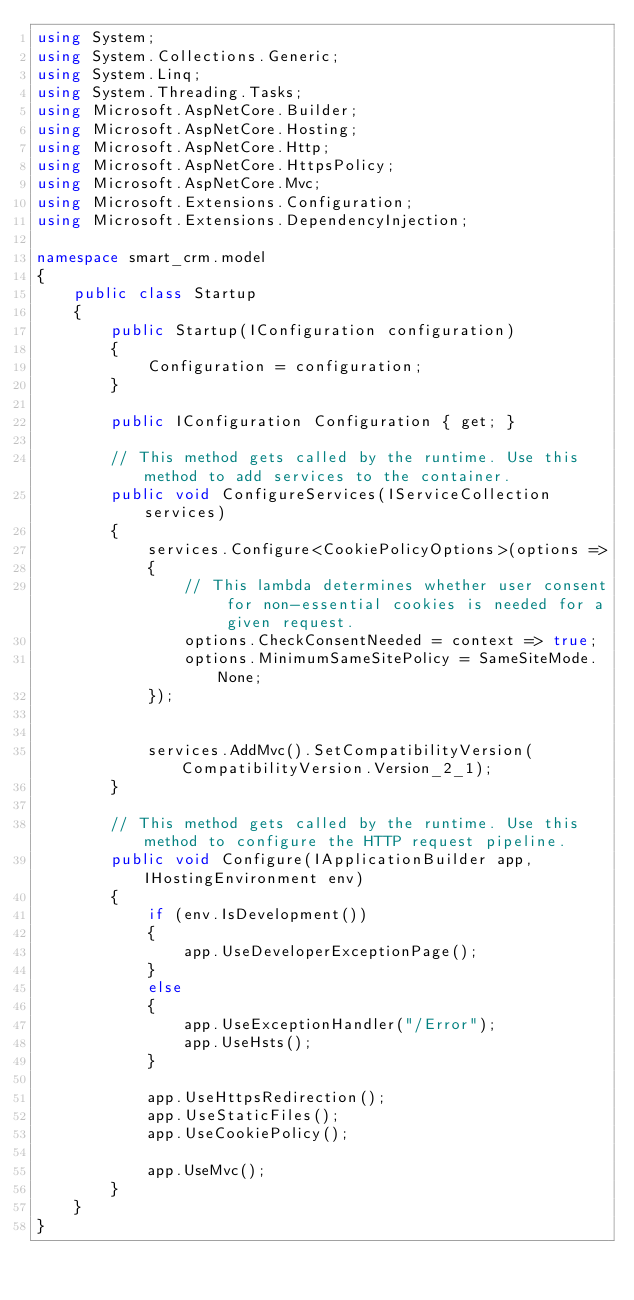<code> <loc_0><loc_0><loc_500><loc_500><_C#_>using System;
using System.Collections.Generic;
using System.Linq;
using System.Threading.Tasks;
using Microsoft.AspNetCore.Builder;
using Microsoft.AspNetCore.Hosting;
using Microsoft.AspNetCore.Http;
using Microsoft.AspNetCore.HttpsPolicy;
using Microsoft.AspNetCore.Mvc;
using Microsoft.Extensions.Configuration;
using Microsoft.Extensions.DependencyInjection;

namespace smart_crm.model
{
    public class Startup
    {
        public Startup(IConfiguration configuration)
        {
            Configuration = configuration;
        }

        public IConfiguration Configuration { get; }

        // This method gets called by the runtime. Use this method to add services to the container.
        public void ConfigureServices(IServiceCollection services)
        {
            services.Configure<CookiePolicyOptions>(options =>
            {
                // This lambda determines whether user consent for non-essential cookies is needed for a given request.
                options.CheckConsentNeeded = context => true;
                options.MinimumSameSitePolicy = SameSiteMode.None;
            });


            services.AddMvc().SetCompatibilityVersion(CompatibilityVersion.Version_2_1);
        }

        // This method gets called by the runtime. Use this method to configure the HTTP request pipeline.
        public void Configure(IApplicationBuilder app, IHostingEnvironment env)
        {
            if (env.IsDevelopment())
            {
                app.UseDeveloperExceptionPage();
            }
            else
            {
                app.UseExceptionHandler("/Error");
                app.UseHsts();
            }

            app.UseHttpsRedirection();
            app.UseStaticFiles();
            app.UseCookiePolicy();

            app.UseMvc();
        }
    }
}
</code> 